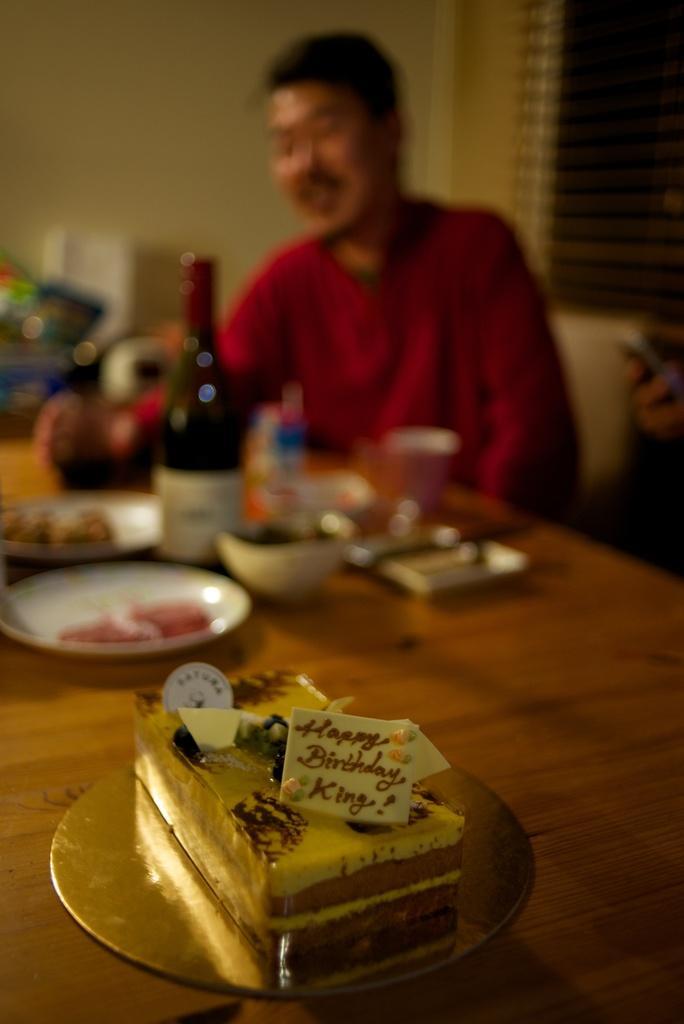Could you give a brief overview of what you see in this image? In this image I can see the person wearing the red color dress and sitting in -front of the table. On the table I can see the bottle, plates with many food items and many other objects to the side. In the background I can see the window blind and the wall. But it is blurry. 